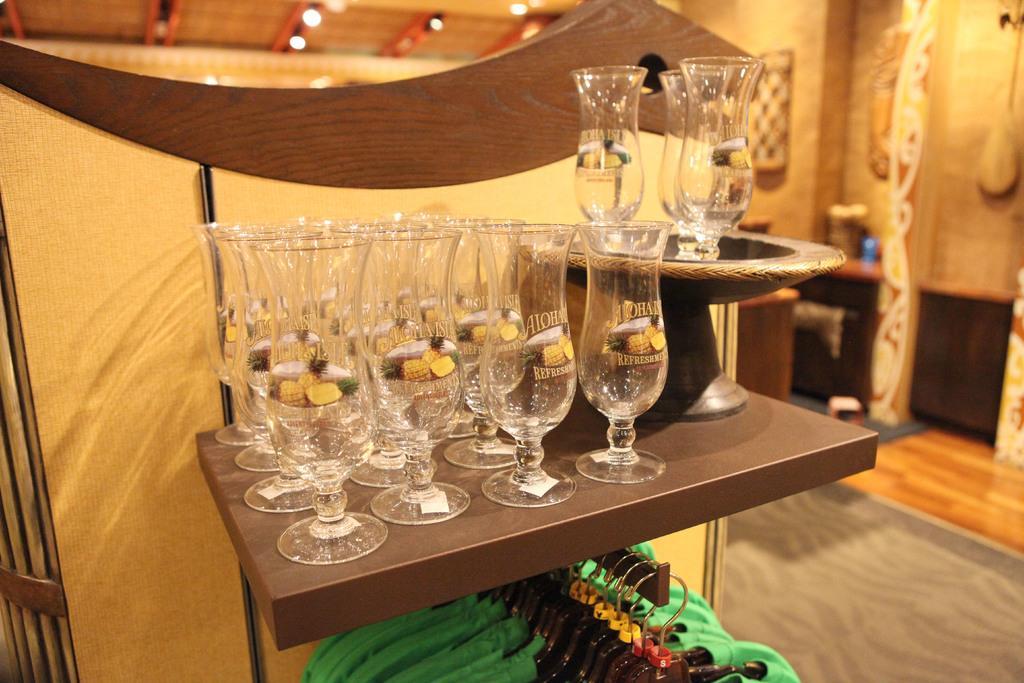In one or two sentences, can you explain what this image depicts? In the image in the center, we can see one table. On the table, we can see glasses and one object. Below the table, we can see hangers and clothes. In the background there is a wall, roof, lights and a few other objects. 